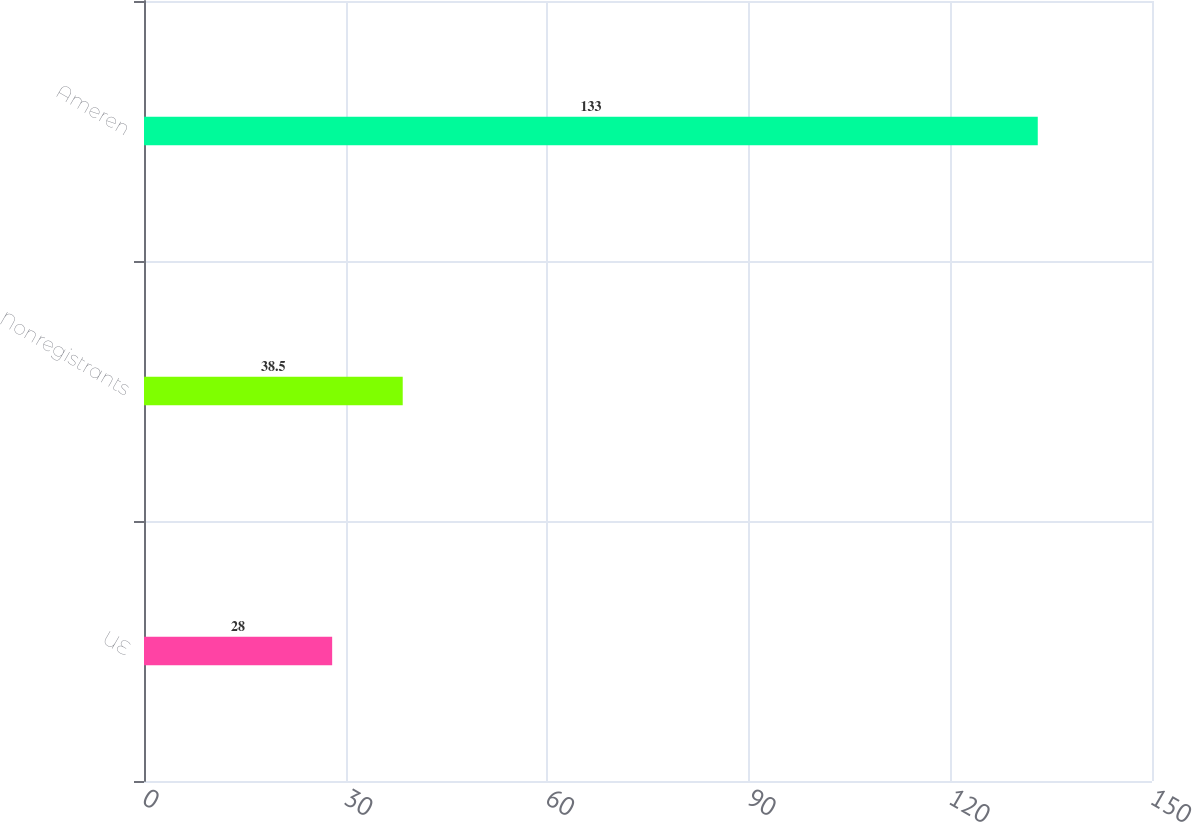Convert chart. <chart><loc_0><loc_0><loc_500><loc_500><bar_chart><fcel>UE<fcel>Nonregistrants<fcel>Ameren<nl><fcel>28<fcel>38.5<fcel>133<nl></chart> 